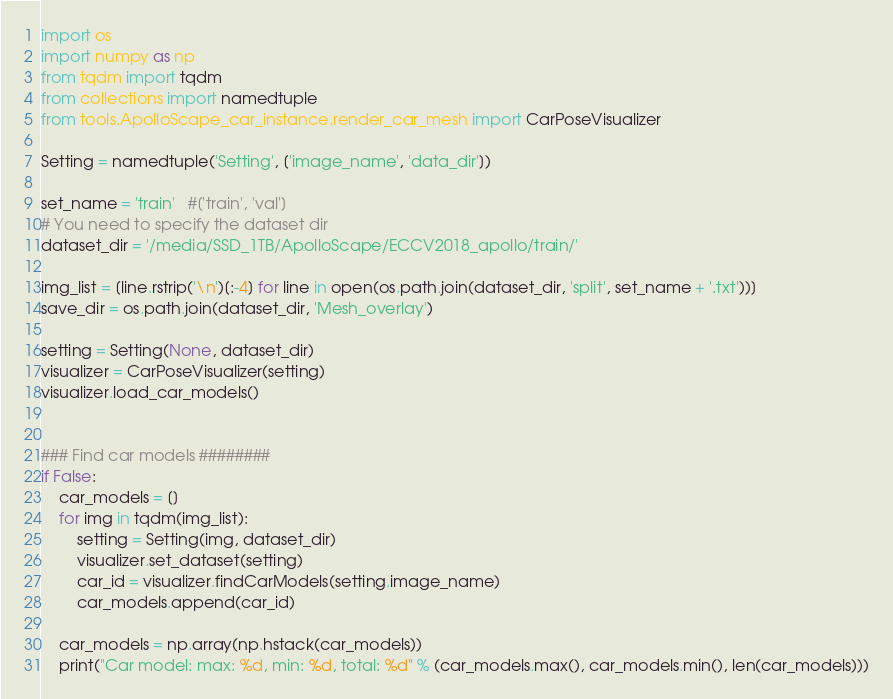<code> <loc_0><loc_0><loc_500><loc_500><_Python_>import os
import numpy as np
from tqdm import tqdm
from collections import namedtuple
from tools.ApolloScape_car_instance.render_car_mesh import CarPoseVisualizer

Setting = namedtuple('Setting', ['image_name', 'data_dir'])

set_name = 'train'   #['train', 'val']
# You need to specify the dataset dir
dataset_dir = '/media/SSD_1TB/ApolloScape/ECCV2018_apollo/train/'

img_list = [line.rstrip('\n')[:-4] for line in open(os.path.join(dataset_dir, 'split', set_name + '.txt'))]
save_dir = os.path.join(dataset_dir, 'Mesh_overlay')

setting = Setting(None, dataset_dir)
visualizer = CarPoseVisualizer(setting)
visualizer.load_car_models()


### Find car models ########
if False:
    car_models = []
    for img in tqdm(img_list):
        setting = Setting(img, dataset_dir)
        visualizer.set_dataset(setting)
        car_id = visualizer.findCarModels(setting.image_name)
        car_models.append(car_id)

    car_models = np.array(np.hstack(car_models))
    print("Car model: max: %d, min: %d, total: %d" % (car_models.max(), car_models.min(), len(car_models)))</code> 